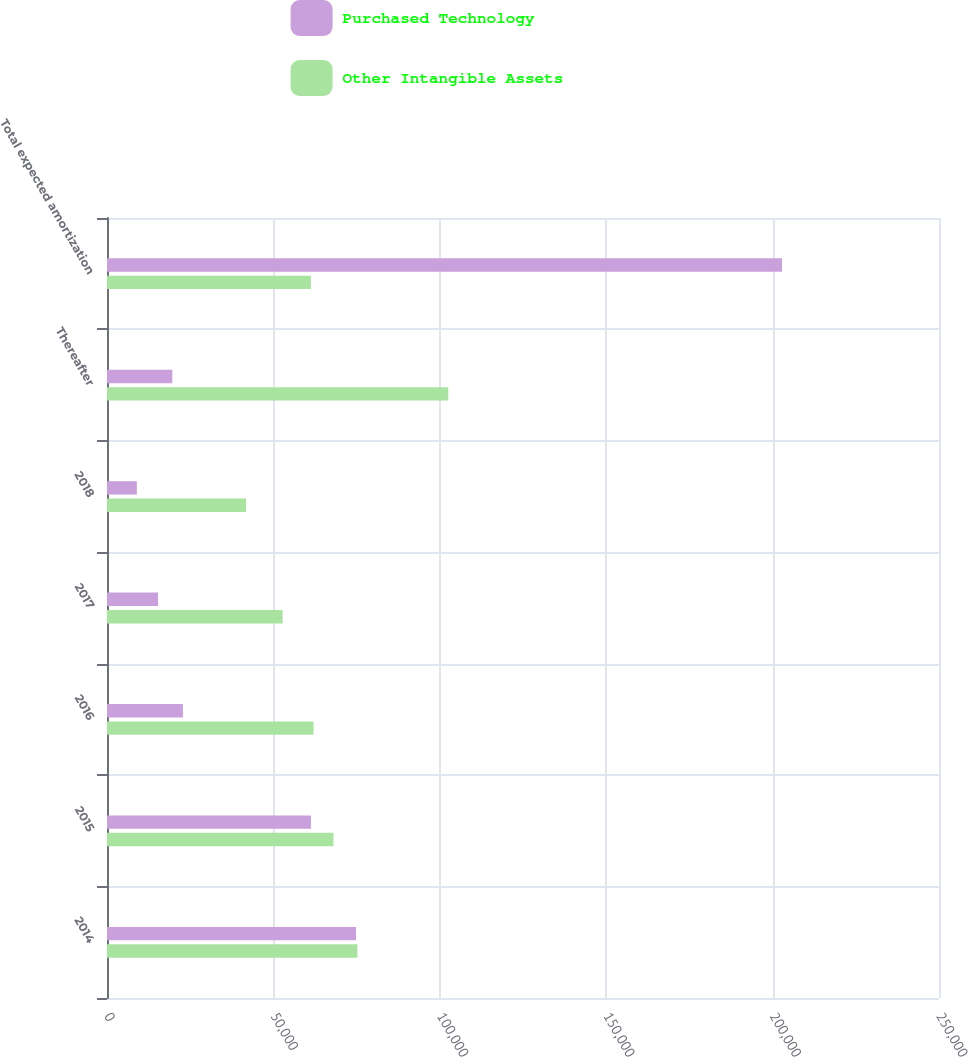<chart> <loc_0><loc_0><loc_500><loc_500><stacked_bar_chart><ecel><fcel>2014<fcel>2015<fcel>2016<fcel>2017<fcel>2018<fcel>Thereafter<fcel>Total expected amortization<nl><fcel>Purchased Technology<fcel>74811<fcel>61273<fcel>22808<fcel>15350<fcel>8961<fcel>19620<fcel>202823<nl><fcel>Other Intangible Assets<fcel>75239<fcel>68041<fcel>62061<fcel>52771<fcel>41779<fcel>102540<fcel>61273<nl></chart> 